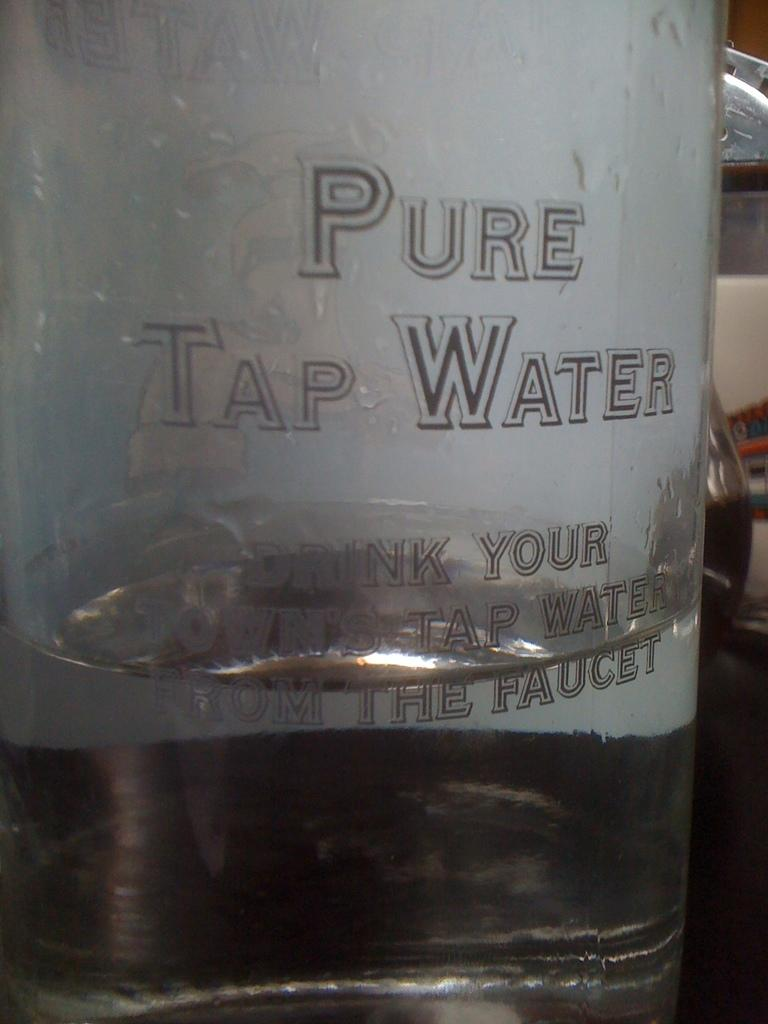<image>
Give a short and clear explanation of the subsequent image. Pure tap water faucet filtration system for drinking water. 